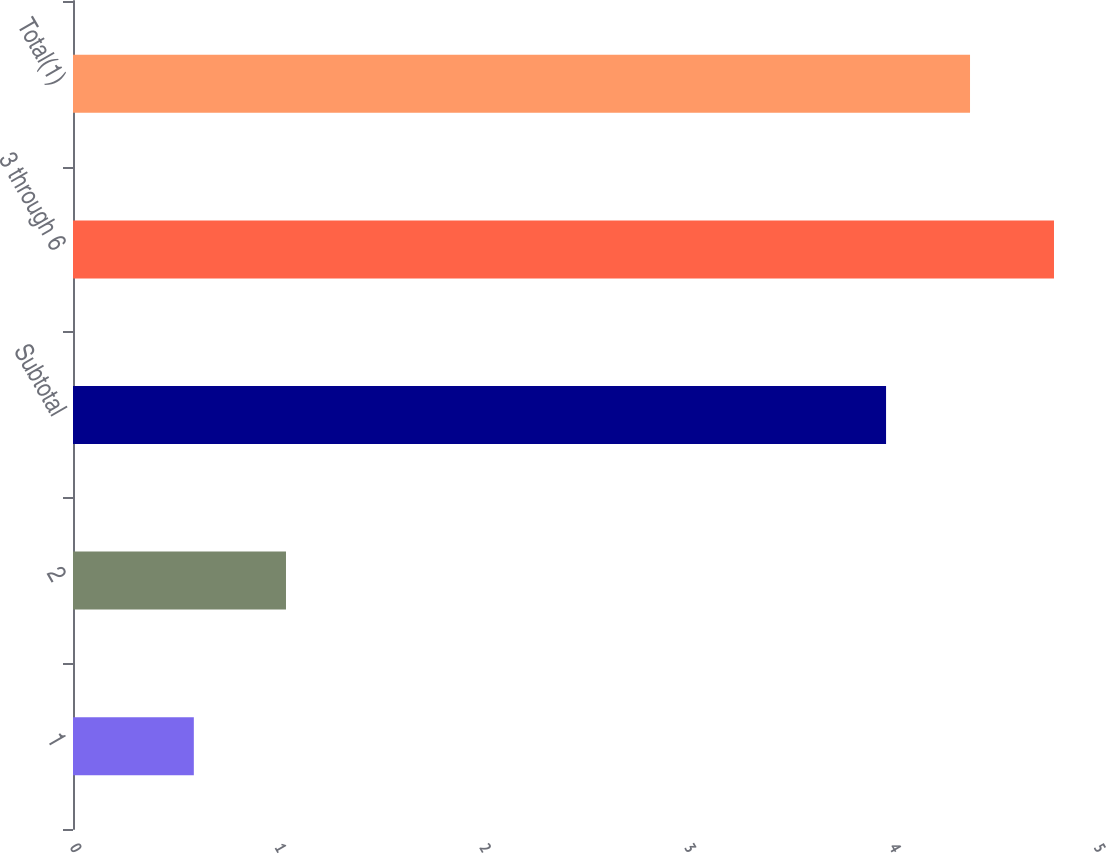Convert chart. <chart><loc_0><loc_0><loc_500><loc_500><bar_chart><fcel>1<fcel>2<fcel>Subtotal<fcel>3 through 6<fcel>Total(1)<nl><fcel>0.59<fcel>1.04<fcel>3.97<fcel>4.79<fcel>4.38<nl></chart> 